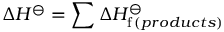<formula> <loc_0><loc_0><loc_500><loc_500>\Delta H ^ { \ominus } = \sum \Delta H _ { f \, ( p r o d u c t s ) } ^ { \ominus }</formula> 